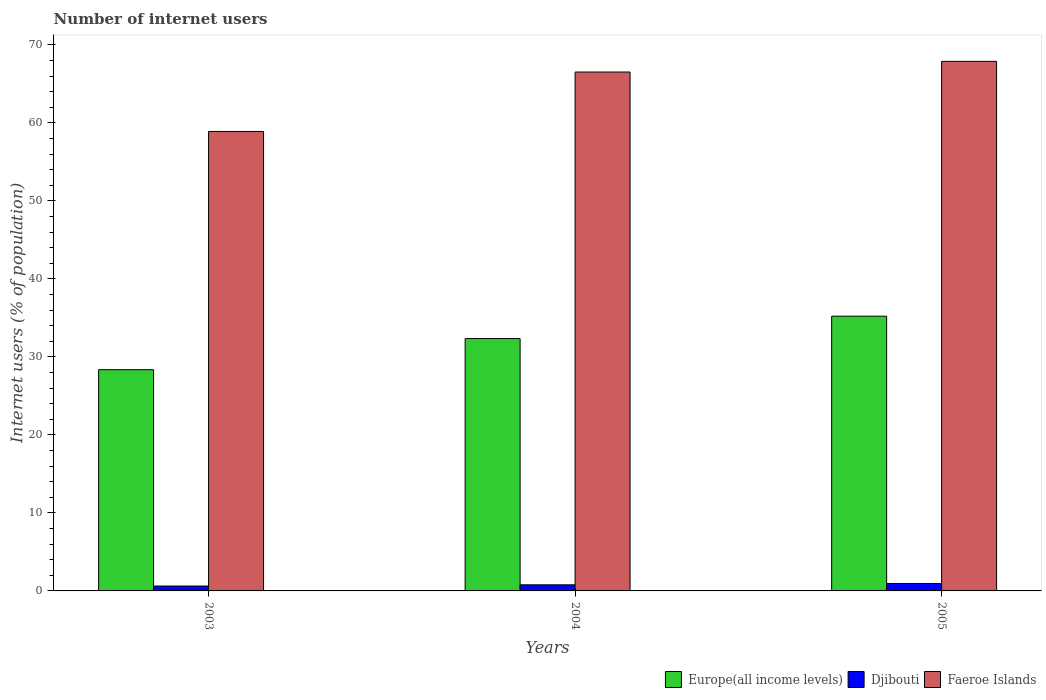How many different coloured bars are there?
Your answer should be compact. 3. Are the number of bars on each tick of the X-axis equal?
Offer a very short reply. Yes. What is the label of the 2nd group of bars from the left?
Your response must be concise. 2004. In how many cases, is the number of bars for a given year not equal to the number of legend labels?
Provide a short and direct response. 0. What is the number of internet users in Europe(all income levels) in 2003?
Make the answer very short. 28.36. Across all years, what is the maximum number of internet users in Faeroe Islands?
Offer a very short reply. 67.9. Across all years, what is the minimum number of internet users in Faeroe Islands?
Provide a succinct answer. 58.91. In which year was the number of internet users in Djibouti maximum?
Your answer should be compact. 2005. In which year was the number of internet users in Djibouti minimum?
Provide a short and direct response. 2003. What is the total number of internet users in Faeroe Islands in the graph?
Your answer should be compact. 193.35. What is the difference between the number of internet users in Faeroe Islands in 2003 and that in 2004?
Offer a terse response. -7.62. What is the difference between the number of internet users in Djibouti in 2005 and the number of internet users in Europe(all income levels) in 2003?
Your response must be concise. -27.41. What is the average number of internet users in Faeroe Islands per year?
Give a very brief answer. 64.45. In the year 2003, what is the difference between the number of internet users in Djibouti and number of internet users in Europe(all income levels)?
Give a very brief answer. -27.74. What is the ratio of the number of internet users in Faeroe Islands in 2004 to that in 2005?
Provide a short and direct response. 0.98. Is the number of internet users in Europe(all income levels) in 2003 less than that in 2005?
Make the answer very short. Yes. What is the difference between the highest and the second highest number of internet users in Djibouti?
Ensure brevity in your answer.  0.17. What is the difference between the highest and the lowest number of internet users in Faeroe Islands?
Your response must be concise. 8.99. In how many years, is the number of internet users in Faeroe Islands greater than the average number of internet users in Faeroe Islands taken over all years?
Provide a short and direct response. 2. What does the 2nd bar from the left in 2003 represents?
Make the answer very short. Djibouti. What does the 1st bar from the right in 2003 represents?
Your answer should be very brief. Faeroe Islands. Is it the case that in every year, the sum of the number of internet users in Faeroe Islands and number of internet users in Djibouti is greater than the number of internet users in Europe(all income levels)?
Give a very brief answer. Yes. How many bars are there?
Provide a short and direct response. 9. Are the values on the major ticks of Y-axis written in scientific E-notation?
Ensure brevity in your answer.  No. Does the graph contain any zero values?
Make the answer very short. No. Does the graph contain grids?
Your answer should be very brief. No. Where does the legend appear in the graph?
Make the answer very short. Bottom right. How many legend labels are there?
Your response must be concise. 3. How are the legend labels stacked?
Keep it short and to the point. Horizontal. What is the title of the graph?
Offer a terse response. Number of internet users. Does "New Zealand" appear as one of the legend labels in the graph?
Provide a succinct answer. No. What is the label or title of the X-axis?
Make the answer very short. Years. What is the label or title of the Y-axis?
Make the answer very short. Internet users (% of population). What is the Internet users (% of population) of Europe(all income levels) in 2003?
Offer a terse response. 28.36. What is the Internet users (% of population) in Djibouti in 2003?
Keep it short and to the point. 0.63. What is the Internet users (% of population) in Faeroe Islands in 2003?
Offer a very short reply. 58.91. What is the Internet users (% of population) in Europe(all income levels) in 2004?
Keep it short and to the point. 32.36. What is the Internet users (% of population) in Djibouti in 2004?
Keep it short and to the point. 0.78. What is the Internet users (% of population) in Faeroe Islands in 2004?
Your response must be concise. 66.53. What is the Internet users (% of population) of Europe(all income levels) in 2005?
Provide a succinct answer. 35.23. What is the Internet users (% of population) of Djibouti in 2005?
Offer a terse response. 0.95. What is the Internet users (% of population) in Faeroe Islands in 2005?
Provide a succinct answer. 67.9. Across all years, what is the maximum Internet users (% of population) of Europe(all income levels)?
Offer a very short reply. 35.23. Across all years, what is the maximum Internet users (% of population) in Djibouti?
Make the answer very short. 0.95. Across all years, what is the maximum Internet users (% of population) of Faeroe Islands?
Your answer should be compact. 67.9. Across all years, what is the minimum Internet users (% of population) of Europe(all income levels)?
Keep it short and to the point. 28.36. Across all years, what is the minimum Internet users (% of population) of Djibouti?
Make the answer very short. 0.63. Across all years, what is the minimum Internet users (% of population) of Faeroe Islands?
Make the answer very short. 58.91. What is the total Internet users (% of population) of Europe(all income levels) in the graph?
Ensure brevity in your answer.  95.95. What is the total Internet users (% of population) of Djibouti in the graph?
Your answer should be very brief. 2.36. What is the total Internet users (% of population) in Faeroe Islands in the graph?
Your answer should be compact. 193.35. What is the difference between the Internet users (% of population) in Europe(all income levels) in 2003 and that in 2004?
Keep it short and to the point. -4. What is the difference between the Internet users (% of population) of Djibouti in 2003 and that in 2004?
Give a very brief answer. -0.16. What is the difference between the Internet users (% of population) in Faeroe Islands in 2003 and that in 2004?
Your response must be concise. -7.62. What is the difference between the Internet users (% of population) of Europe(all income levels) in 2003 and that in 2005?
Provide a short and direct response. -6.86. What is the difference between the Internet users (% of population) in Djibouti in 2003 and that in 2005?
Your answer should be compact. -0.33. What is the difference between the Internet users (% of population) of Faeroe Islands in 2003 and that in 2005?
Ensure brevity in your answer.  -8.99. What is the difference between the Internet users (% of population) in Europe(all income levels) in 2004 and that in 2005?
Your response must be concise. -2.87. What is the difference between the Internet users (% of population) of Djibouti in 2004 and that in 2005?
Offer a very short reply. -0.17. What is the difference between the Internet users (% of population) in Faeroe Islands in 2004 and that in 2005?
Provide a succinct answer. -1.37. What is the difference between the Internet users (% of population) of Europe(all income levels) in 2003 and the Internet users (% of population) of Djibouti in 2004?
Keep it short and to the point. 27.58. What is the difference between the Internet users (% of population) of Europe(all income levels) in 2003 and the Internet users (% of population) of Faeroe Islands in 2004?
Keep it short and to the point. -38.17. What is the difference between the Internet users (% of population) of Djibouti in 2003 and the Internet users (% of population) of Faeroe Islands in 2004?
Offer a terse response. -65.91. What is the difference between the Internet users (% of population) in Europe(all income levels) in 2003 and the Internet users (% of population) in Djibouti in 2005?
Your answer should be very brief. 27.41. What is the difference between the Internet users (% of population) of Europe(all income levels) in 2003 and the Internet users (% of population) of Faeroe Islands in 2005?
Your response must be concise. -39.54. What is the difference between the Internet users (% of population) of Djibouti in 2003 and the Internet users (% of population) of Faeroe Islands in 2005?
Your answer should be compact. -67.28. What is the difference between the Internet users (% of population) in Europe(all income levels) in 2004 and the Internet users (% of population) in Djibouti in 2005?
Make the answer very short. 31.41. What is the difference between the Internet users (% of population) in Europe(all income levels) in 2004 and the Internet users (% of population) in Faeroe Islands in 2005?
Give a very brief answer. -35.54. What is the difference between the Internet users (% of population) of Djibouti in 2004 and the Internet users (% of population) of Faeroe Islands in 2005?
Offer a very short reply. -67.12. What is the average Internet users (% of population) of Europe(all income levels) per year?
Your response must be concise. 31.98. What is the average Internet users (% of population) of Djibouti per year?
Offer a terse response. 0.79. What is the average Internet users (% of population) in Faeroe Islands per year?
Keep it short and to the point. 64.45. In the year 2003, what is the difference between the Internet users (% of population) of Europe(all income levels) and Internet users (% of population) of Djibouti?
Give a very brief answer. 27.74. In the year 2003, what is the difference between the Internet users (% of population) of Europe(all income levels) and Internet users (% of population) of Faeroe Islands?
Offer a very short reply. -30.55. In the year 2003, what is the difference between the Internet users (% of population) of Djibouti and Internet users (% of population) of Faeroe Islands?
Your response must be concise. -58.29. In the year 2004, what is the difference between the Internet users (% of population) of Europe(all income levels) and Internet users (% of population) of Djibouti?
Give a very brief answer. 31.58. In the year 2004, what is the difference between the Internet users (% of population) of Europe(all income levels) and Internet users (% of population) of Faeroe Islands?
Your answer should be compact. -34.17. In the year 2004, what is the difference between the Internet users (% of population) in Djibouti and Internet users (% of population) in Faeroe Islands?
Make the answer very short. -65.75. In the year 2005, what is the difference between the Internet users (% of population) in Europe(all income levels) and Internet users (% of population) in Djibouti?
Give a very brief answer. 34.27. In the year 2005, what is the difference between the Internet users (% of population) in Europe(all income levels) and Internet users (% of population) in Faeroe Islands?
Your answer should be compact. -32.68. In the year 2005, what is the difference between the Internet users (% of population) of Djibouti and Internet users (% of population) of Faeroe Islands?
Give a very brief answer. -66.95. What is the ratio of the Internet users (% of population) of Europe(all income levels) in 2003 to that in 2004?
Your answer should be very brief. 0.88. What is the ratio of the Internet users (% of population) in Djibouti in 2003 to that in 2004?
Provide a short and direct response. 0.8. What is the ratio of the Internet users (% of population) of Faeroe Islands in 2003 to that in 2004?
Ensure brevity in your answer.  0.89. What is the ratio of the Internet users (% of population) of Europe(all income levels) in 2003 to that in 2005?
Ensure brevity in your answer.  0.81. What is the ratio of the Internet users (% of population) in Djibouti in 2003 to that in 2005?
Your answer should be compact. 0.66. What is the ratio of the Internet users (% of population) of Faeroe Islands in 2003 to that in 2005?
Provide a succinct answer. 0.87. What is the ratio of the Internet users (% of population) in Europe(all income levels) in 2004 to that in 2005?
Provide a succinct answer. 0.92. What is the ratio of the Internet users (% of population) in Djibouti in 2004 to that in 2005?
Provide a short and direct response. 0.82. What is the ratio of the Internet users (% of population) of Faeroe Islands in 2004 to that in 2005?
Provide a short and direct response. 0.98. What is the difference between the highest and the second highest Internet users (% of population) of Europe(all income levels)?
Keep it short and to the point. 2.87. What is the difference between the highest and the second highest Internet users (% of population) in Djibouti?
Your response must be concise. 0.17. What is the difference between the highest and the second highest Internet users (% of population) of Faeroe Islands?
Your response must be concise. 1.37. What is the difference between the highest and the lowest Internet users (% of population) in Europe(all income levels)?
Your response must be concise. 6.86. What is the difference between the highest and the lowest Internet users (% of population) in Djibouti?
Your response must be concise. 0.33. What is the difference between the highest and the lowest Internet users (% of population) in Faeroe Islands?
Ensure brevity in your answer.  8.99. 